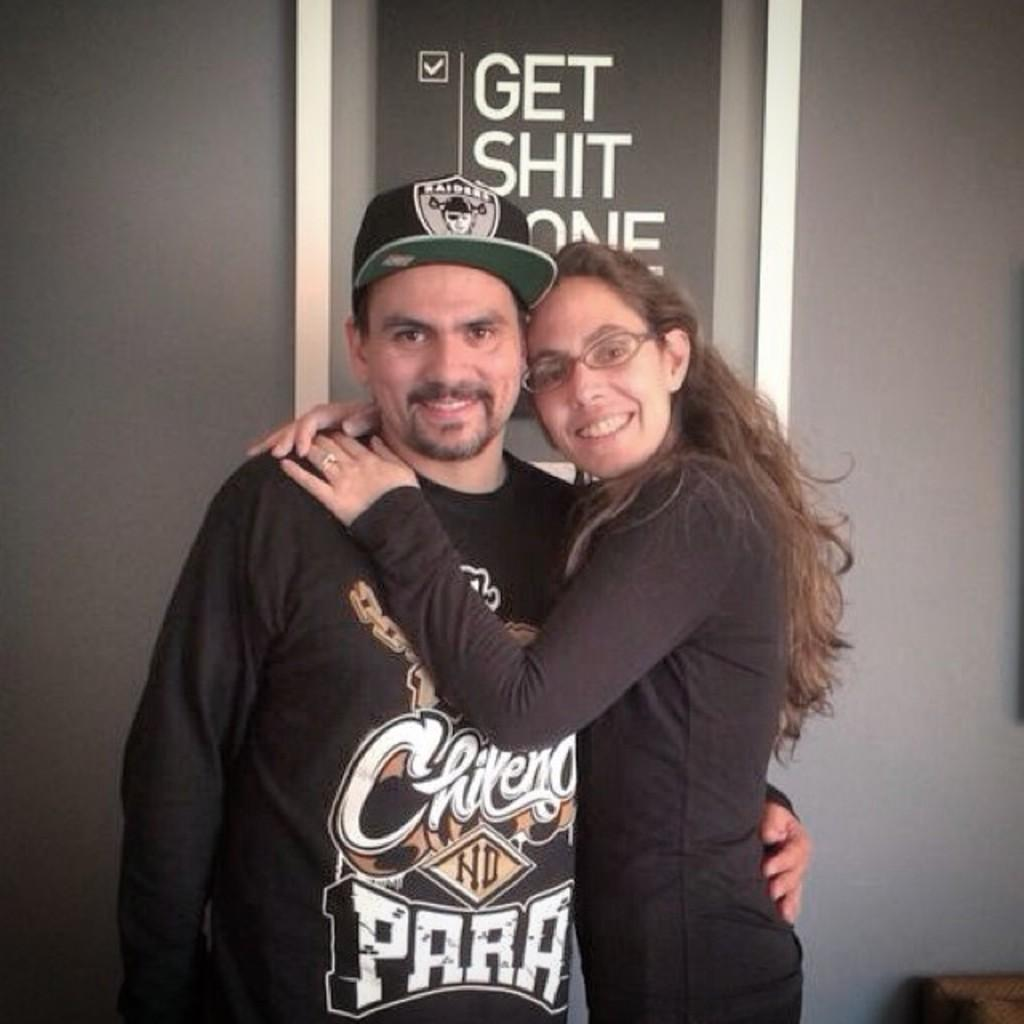<image>
Offer a succinct explanation of the picture presented. A young couple pose in front of a poster instructing people to Get Shit Done. 